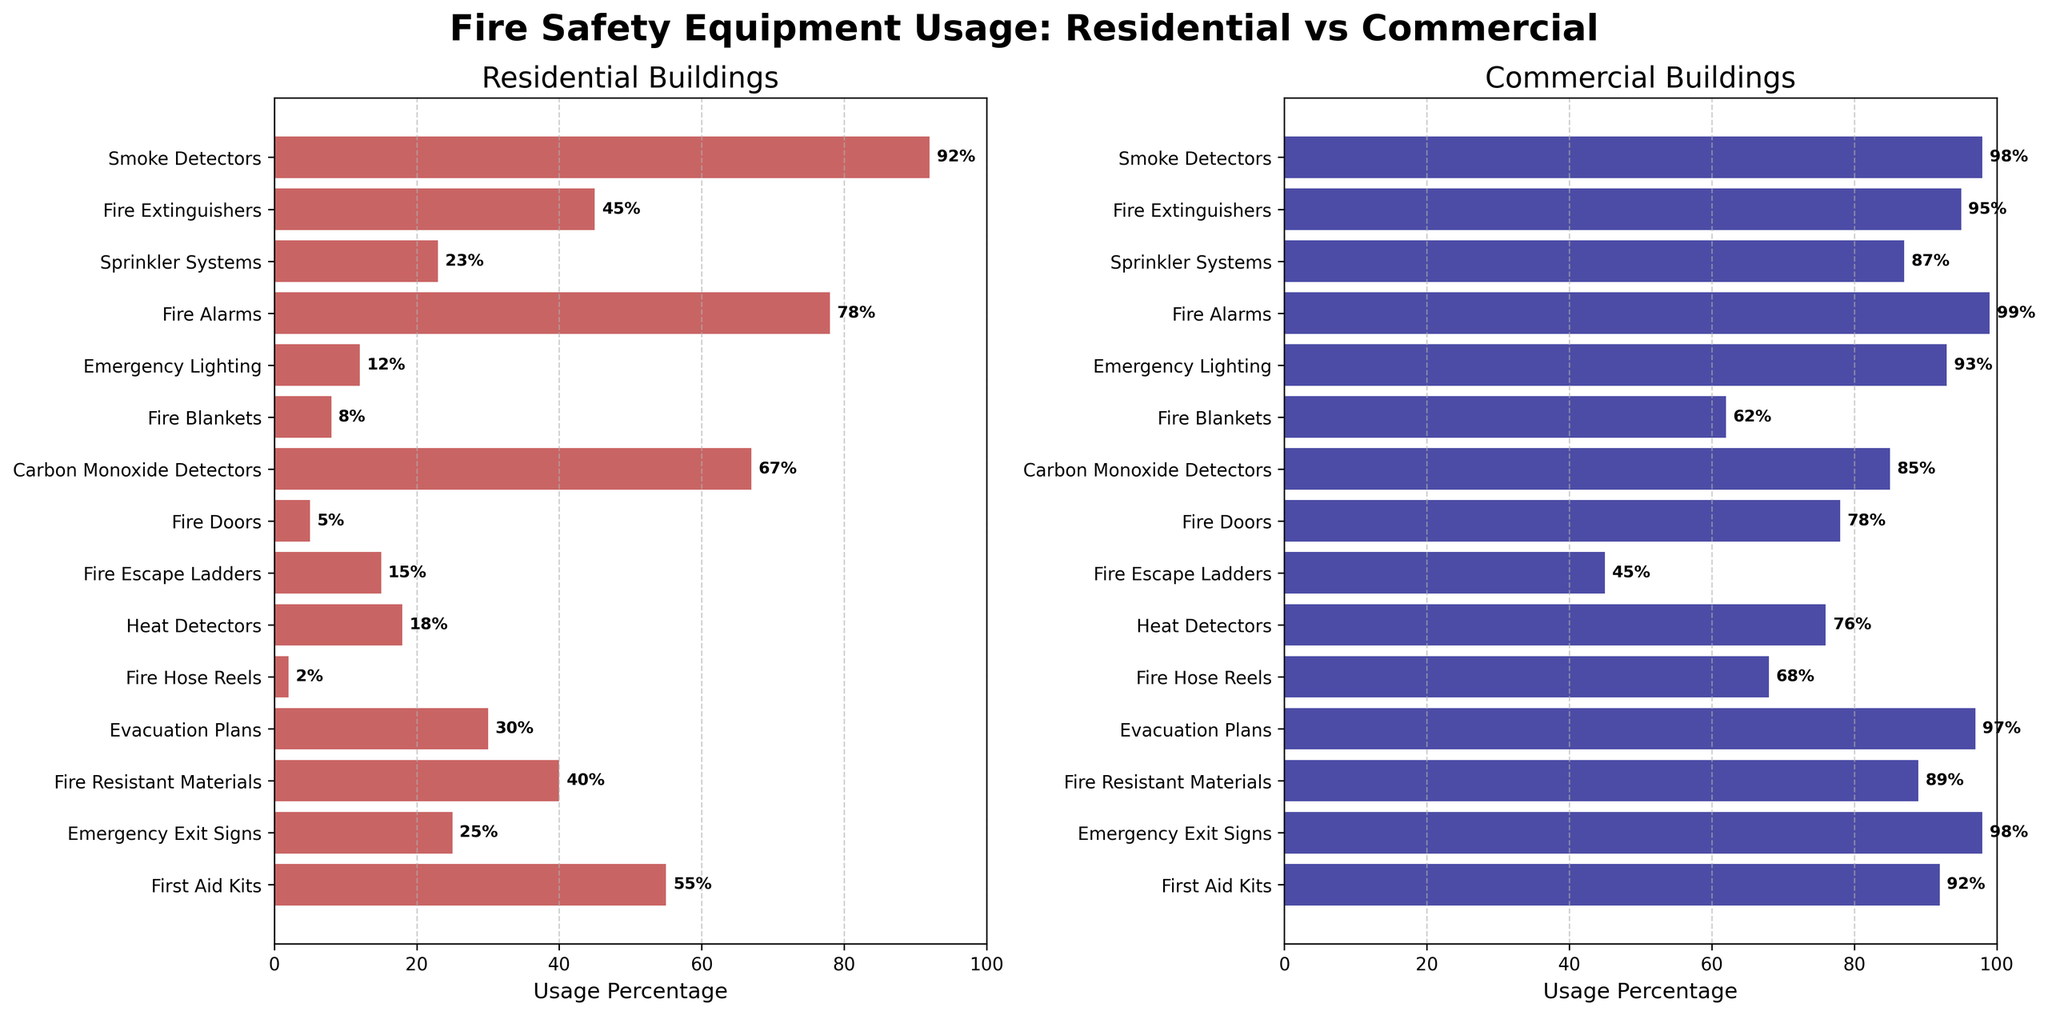Which equipment has the highest usage in commercial buildings? To find the equipment with the highest usage in commercial buildings, look at the commercial plot (in navy) and identify the bar with the greatest length. Compare the lengths to see that "Fire Alarms" has the highest usage with a value of 99%.
Answer: Fire Alarms Which equipment has the lowest usage in residential buildings? To identify the equipment with the lowest usage in residential buildings, look at the residential plot (in firebrick) and find the shortest bar. "Fire Hose Reels" has the shortest bar with a value of 2%.
Answer: Fire Hose Reels What is the difference in usage percentage between smoke detectors in residential and commercial buildings? Check the length of the bars for smoke detectors in both subplots. For residential, the value is 92%. For commercial, it is 98%. Calculate the difference: 98% - 92% = 6%.
Answer: 6% Which type of equipment has a greater difference in usage percentage between residential and commercial buildings, fire extinguishers or emergency lighting? For fire extinguishers, find the difference between residential (45%) and commercial (95%): 95% - 45% = 50%. For emergency lighting, the difference is between residential (12%) and commercial (93%): 93% - 12% = 81%. Emergency lighting has a greater difference.
Answer: Emergency Lighting How many types of equipment have a usage percentage above 90% in commercial buildings? Count the number of bars in the commercial subplot (in navy) with usage percentages above 90%. They are: Smoke Detectors, Fire Extinguishers, Sprinkler Systems, Fire Alarms, Emergency Lighting, Carbon Monoxide Detectors, Evacuation Plans, Fire Resistant Materials, Emergency Exit Signs, and First Aid Kits. There are 10 such types of equipment.
Answer: 10 How many equipment types have a higher usage percentage in residential buildings compared to commercial buildings? Compare the lengths of corresponding bars in both subplots. Equipment with higher residential usage are: Fire Escape Ladders, Fire Blankets, First Aid Kits, and Heat Detectors. In total, there are 4 such types of equipment.
Answer: 4 What is the average usage percentage of fire safety equipment in residential buildings? Sum the usage percentages for all equipment in residential buildings and divide by the number of equipment types. The total is 92 + 45 + 23 + 78 + 12 + 8 + 67 + 5 + 15 + 18 + 2 + 30 + 40 + 25 + 55 = 515. There are 15 equipment types, so the average is 515 / 15 ≈ 34.33.
Answer: 34.33 Is the usage percentage of emergency exit signs higher in residential or commercial buildings? Compare the lengths of the bars for emergency exit signs in both subplots. Residential usage is 25% and commercial usage is 98%. The usage percentage is higher in commercial buildings.
Answer: Commercial Which equipment has the smallest difference in usage between residential and commercial buildings? Calculate the differences for all equipment types. Smoke Detectors have a difference of 6% (98% - 92%), which is the smallest among all.
Answer: Smoke Detectors Which type of building has a generally higher usage percentage of fire safety equipment? Compare the general lengths of bars in both subplots. The commercial subplot (in navy) generally has longer bars compared to the residential subplot (in firebrick).
Answer: Commercial 